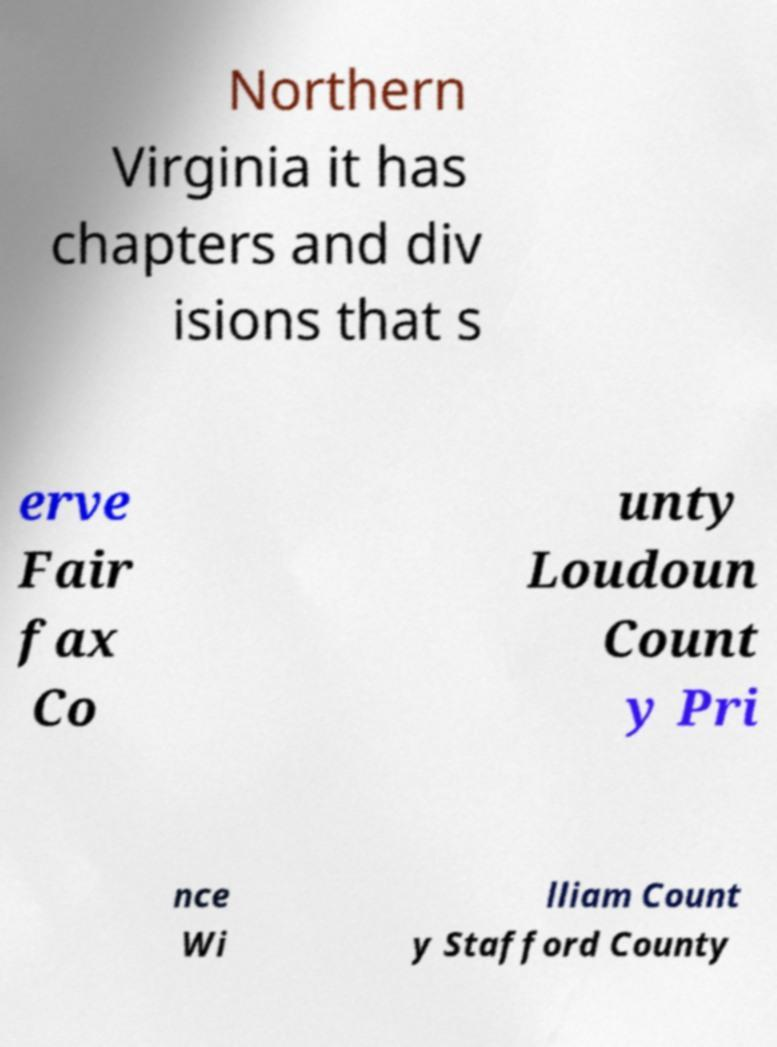Please identify and transcribe the text found in this image. Northern Virginia it has chapters and div isions that s erve Fair fax Co unty Loudoun Count y Pri nce Wi lliam Count y Stafford County 